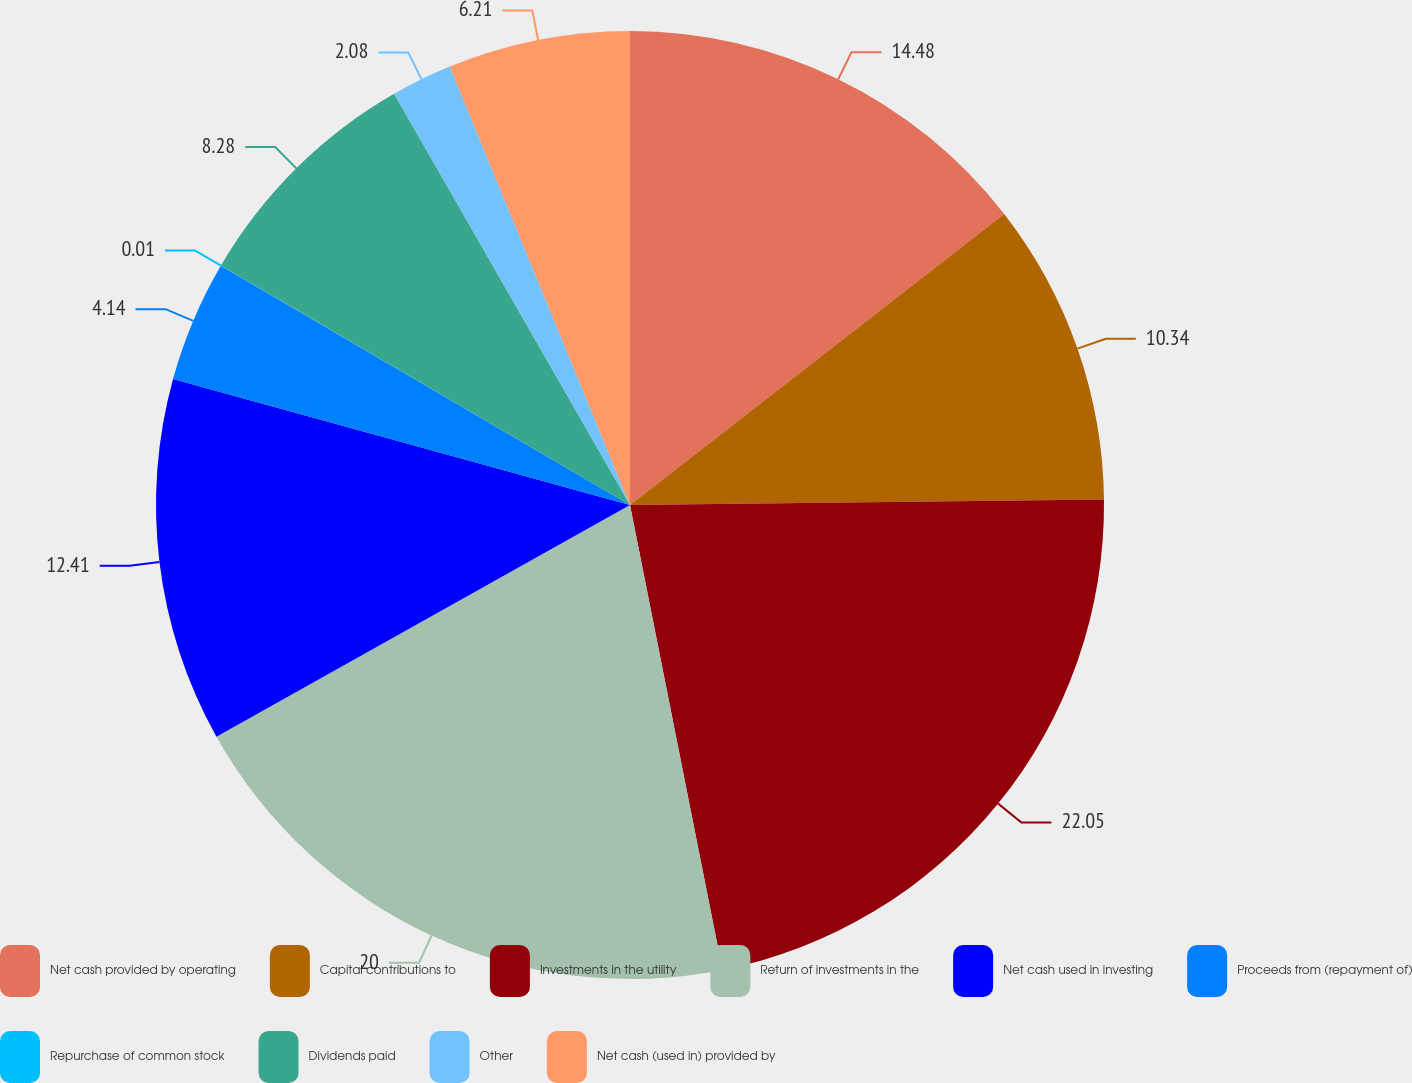Convert chart to OTSL. <chart><loc_0><loc_0><loc_500><loc_500><pie_chart><fcel>Net cash provided by operating<fcel>Capital contributions to<fcel>Investments in the utility<fcel>Return of investments in the<fcel>Net cash used in investing<fcel>Proceeds from (repayment of)<fcel>Repurchase of common stock<fcel>Dividends paid<fcel>Other<fcel>Net cash (used in) provided by<nl><fcel>14.48%<fcel>10.34%<fcel>22.06%<fcel>20.0%<fcel>12.41%<fcel>4.14%<fcel>0.01%<fcel>8.28%<fcel>2.08%<fcel>6.21%<nl></chart> 